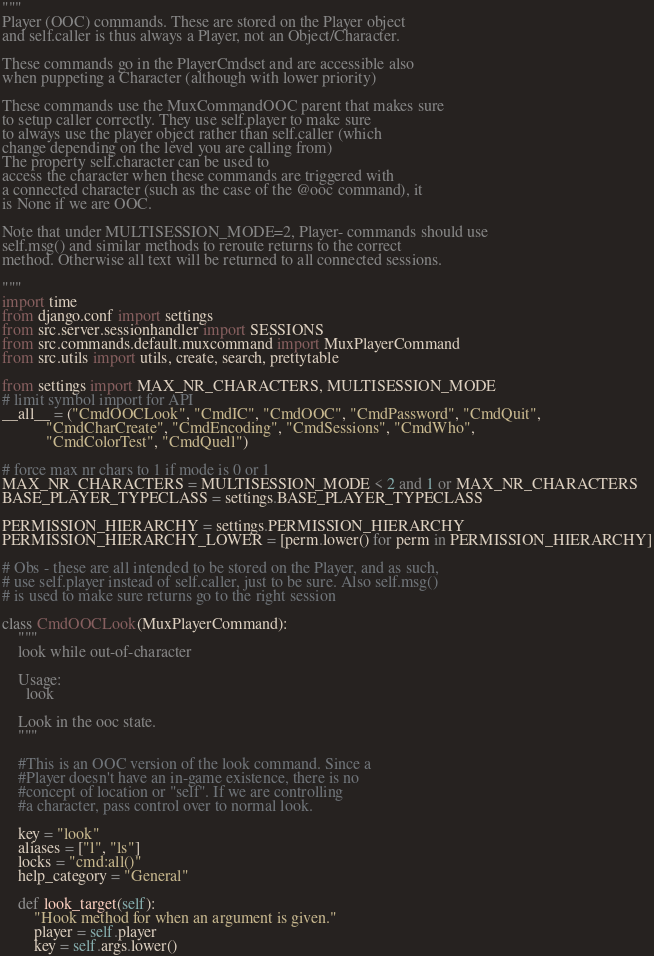<code> <loc_0><loc_0><loc_500><loc_500><_Python_>"""
Player (OOC) commands. These are stored on the Player object
and self.caller is thus always a Player, not an Object/Character.

These commands go in the PlayerCmdset and are accessible also
when puppeting a Character (although with lower priority)

These commands use the MuxCommandOOC parent that makes sure
to setup caller correctly. They use self.player to make sure
to always use the player object rather than self.caller (which
change depending on the level you are calling from)
The property self.character can be used to
access the character when these commands are triggered with
a connected character (such as the case of the @ooc command), it
is None if we are OOC.

Note that under MULTISESSION_MODE=2, Player- commands should use
self.msg() and similar methods to reroute returns to the correct
method. Otherwise all text will be returned to all connected sessions.

"""
import time
from django.conf import settings
from src.server.sessionhandler import SESSIONS
from src.commands.default.muxcommand import MuxPlayerCommand
from src.utils import utils, create, search, prettytable

from settings import MAX_NR_CHARACTERS, MULTISESSION_MODE
# limit symbol import for API
__all__ = ("CmdOOCLook", "CmdIC", "CmdOOC", "CmdPassword", "CmdQuit",
           "CmdCharCreate", "CmdEncoding", "CmdSessions", "CmdWho",
           "CmdColorTest", "CmdQuell")

# force max nr chars to 1 if mode is 0 or 1
MAX_NR_CHARACTERS = MULTISESSION_MODE < 2 and 1 or MAX_NR_CHARACTERS
BASE_PLAYER_TYPECLASS = settings.BASE_PLAYER_TYPECLASS

PERMISSION_HIERARCHY = settings.PERMISSION_HIERARCHY
PERMISSION_HIERARCHY_LOWER = [perm.lower() for perm in PERMISSION_HIERARCHY]

# Obs - these are all intended to be stored on the Player, and as such,
# use self.player instead of self.caller, just to be sure. Also self.msg()
# is used to make sure returns go to the right session

class CmdOOCLook(MuxPlayerCommand):
    """
    look while out-of-character

    Usage:
      look

    Look in the ooc state.
    """

    #This is an OOC version of the look command. Since a
    #Player doesn't have an in-game existence, there is no
    #concept of location or "self". If we are controlling
    #a character, pass control over to normal look.

    key = "look"
    aliases = ["l", "ls"]
    locks = "cmd:all()"
    help_category = "General"

    def look_target(self):
        "Hook method for when an argument is given."
        player = self.player
        key = self.args.lower()</code> 